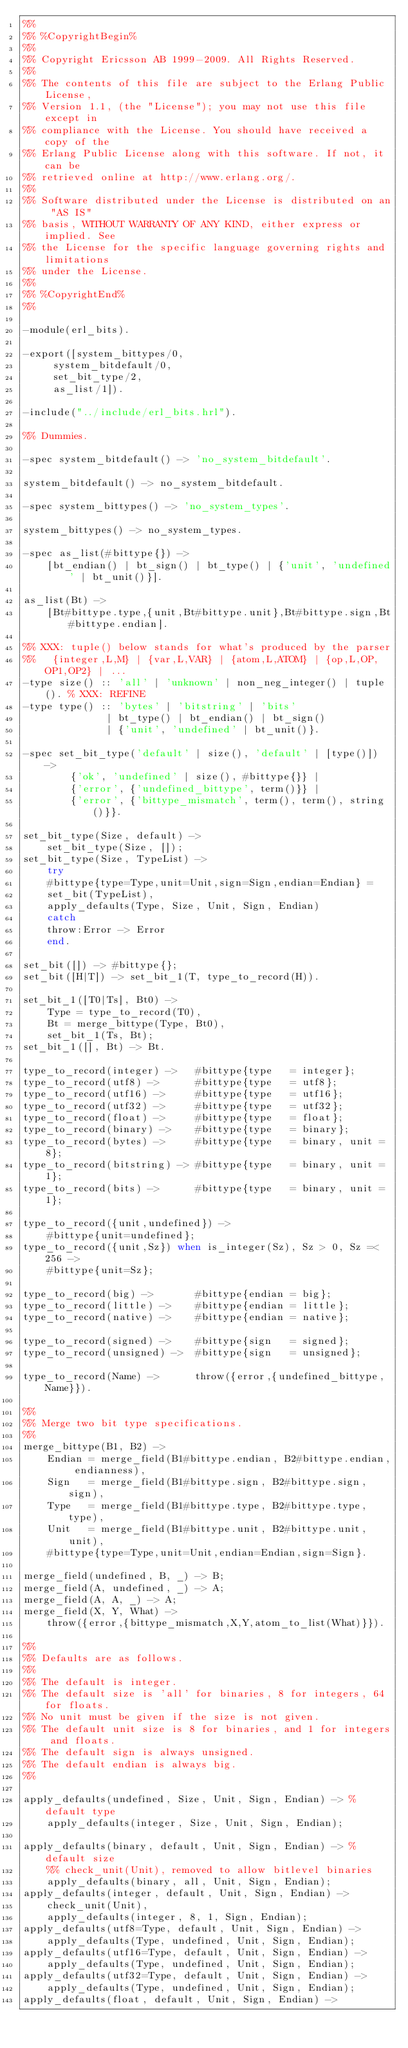Convert code to text. <code><loc_0><loc_0><loc_500><loc_500><_Erlang_>%%
%% %CopyrightBegin%
%% 
%% Copyright Ericsson AB 1999-2009. All Rights Reserved.
%% 
%% The contents of this file are subject to the Erlang Public License,
%% Version 1.1, (the "License"); you may not use this file except in
%% compliance with the License. You should have received a copy of the
%% Erlang Public License along with this software. If not, it can be
%% retrieved online at http://www.erlang.org/.
%% 
%% Software distributed under the License is distributed on an "AS IS"
%% basis, WITHOUT WARRANTY OF ANY KIND, either express or implied. See
%% the License for the specific language governing rights and limitations
%% under the License.
%% 
%% %CopyrightEnd%
%%

-module(erl_bits).

-export([system_bittypes/0, 
	 system_bitdefault/0,
	 set_bit_type/2,
	 as_list/1]).

-include("../include/erl_bits.hrl").

%% Dummies.

-spec system_bitdefault() -> 'no_system_bitdefault'.

system_bitdefault() -> no_system_bitdefault.

-spec system_bittypes() -> 'no_system_types'.

system_bittypes() -> no_system_types.

-spec as_list(#bittype{}) ->
    [bt_endian() | bt_sign() | bt_type() | {'unit', 'undefined' | bt_unit()}].

as_list(Bt) ->
    [Bt#bittype.type,{unit,Bt#bittype.unit},Bt#bittype.sign,Bt#bittype.endian].

%% XXX: tuple() below stands for what's produced by the parser
%%   {integer,L,M} | {var,L,VAR} | {atom,L,ATOM} | {op,L,OP,OP1,OP2} | ...
-type size() :: 'all' | 'unknown' | non_neg_integer() | tuple(). % XXX: REFINE
-type type() :: 'bytes' | 'bitstring' | 'bits'
              | bt_type() | bt_endian() | bt_sign()
              | {'unit', 'undefined' | bt_unit()}.

-spec set_bit_type('default' | size(), 'default' | [type()]) ->
        {'ok', 'undefined' | size(), #bittype{}} |
        {'error', {'undefined_bittype', term()}} |
        {'error', {'bittype_mismatch', term(), term(), string()}}.

set_bit_type(Size, default) ->
    set_bit_type(Size, []);
set_bit_type(Size, TypeList) ->
    try
	#bittype{type=Type,unit=Unit,sign=Sign,endian=Endian} =
	set_bit(TypeList),
	apply_defaults(Type, Size, Unit, Sign, Endian)
    catch
	throw:Error -> Error
    end.

set_bit([]) -> #bittype{};
set_bit([H|T]) -> set_bit_1(T, type_to_record(H)).

set_bit_1([T0|Ts], Bt0) ->
    Type = type_to_record(T0),
    Bt = merge_bittype(Type, Bt0),
    set_bit_1(Ts, Bt);
set_bit_1([], Bt) -> Bt.

type_to_record(integer) ->   #bittype{type   = integer};
type_to_record(utf8) ->      #bittype{type   = utf8};
type_to_record(utf16) ->     #bittype{type   = utf16};
type_to_record(utf32) ->     #bittype{type   = utf32};
type_to_record(float) ->     #bittype{type   = float};
type_to_record(binary) ->    #bittype{type   = binary};
type_to_record(bytes) ->     #bittype{type   = binary, unit = 8};
type_to_record(bitstring) -> #bittype{type   = binary, unit = 1};
type_to_record(bits) ->      #bittype{type   = binary, unit = 1};

type_to_record({unit,undefined}) ->
    #bittype{unit=undefined};
type_to_record({unit,Sz}) when is_integer(Sz), Sz > 0, Sz =< 256 ->
    #bittype{unit=Sz};

type_to_record(big) ->       #bittype{endian = big};
type_to_record(little) ->    #bittype{endian = little};
type_to_record(native) ->    #bittype{endian = native};

type_to_record(signed) ->    #bittype{sign   = signed};
type_to_record(unsigned) ->  #bittype{sign   = unsigned};

type_to_record(Name) ->      throw({error,{undefined_bittype,Name}}).

%%
%% Merge two bit type specifications.
%%
merge_bittype(B1, B2) ->
    Endian = merge_field(B1#bittype.endian, B2#bittype.endian, endianness),
    Sign   = merge_field(B1#bittype.sign, B2#bittype.sign, sign),
    Type   = merge_field(B1#bittype.type, B2#bittype.type, type),
    Unit   = merge_field(B1#bittype.unit, B2#bittype.unit, unit),
    #bittype{type=Type,unit=Unit,endian=Endian,sign=Sign}.

merge_field(undefined, B, _) -> B;
merge_field(A, undefined, _) -> A;
merge_field(A, A, _) -> A;
merge_field(X, Y, What) ->
    throw({error,{bittype_mismatch,X,Y,atom_to_list(What)}}).

%%
%% Defaults are as follows.
%% 
%% The default is integer.
%% The default size is 'all' for binaries, 8 for integers, 64 for floats.
%% No unit must be given if the size is not given.
%% The default unit size is 8 for binaries, and 1 for integers and floats.
%% The default sign is always unsigned.
%% The default endian is always big.
%%

apply_defaults(undefined, Size, Unit, Sign, Endian) -> %default type
    apply_defaults(integer, Size, Unit, Sign, Endian);

apply_defaults(binary, default, Unit, Sign, Endian) -> %default size
    %% check_unit(Unit), removed to allow bitlevel binaries
    apply_defaults(binary, all, Unit, Sign, Endian);
apply_defaults(integer, default, Unit, Sign, Endian) ->
    check_unit(Unit),
    apply_defaults(integer, 8, 1, Sign, Endian);
apply_defaults(utf8=Type, default, Unit, Sign, Endian) ->
    apply_defaults(Type, undefined, Unit, Sign, Endian);
apply_defaults(utf16=Type, default, Unit, Sign, Endian) ->
    apply_defaults(Type, undefined, Unit, Sign, Endian);
apply_defaults(utf32=Type, default, Unit, Sign, Endian) ->
    apply_defaults(Type, undefined, Unit, Sign, Endian);
apply_defaults(float, default, Unit, Sign, Endian) -></code> 